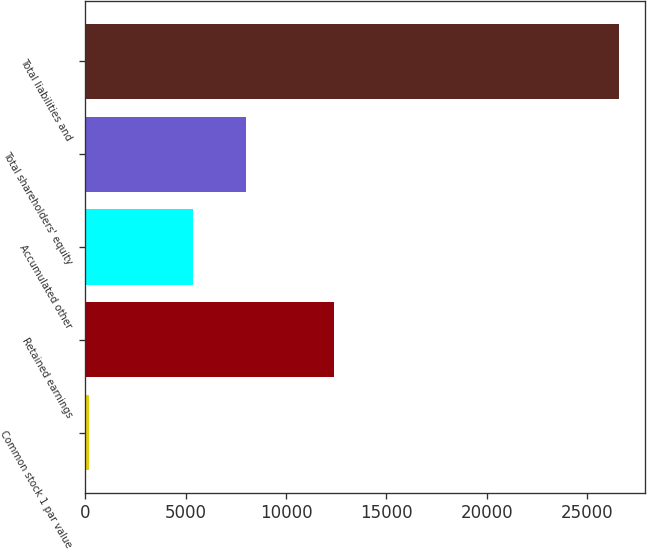Convert chart to OTSL. <chart><loc_0><loc_0><loc_500><loc_500><bar_chart><fcel>Common stock 1 par value<fcel>Retained earnings<fcel>Accumulated other<fcel>Total shareholders' equity<fcel>Total liabilities and<nl><fcel>199<fcel>12392<fcel>5356<fcel>7993.3<fcel>26572<nl></chart> 